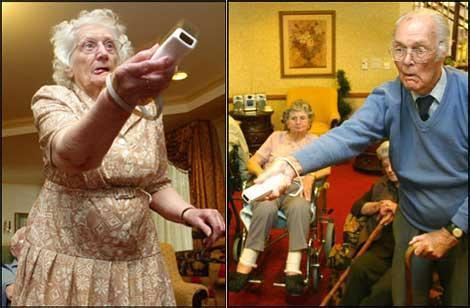How many people are in the photo?
Give a very brief answer. 3. How many wood bowls are on the left?
Give a very brief answer. 0. 